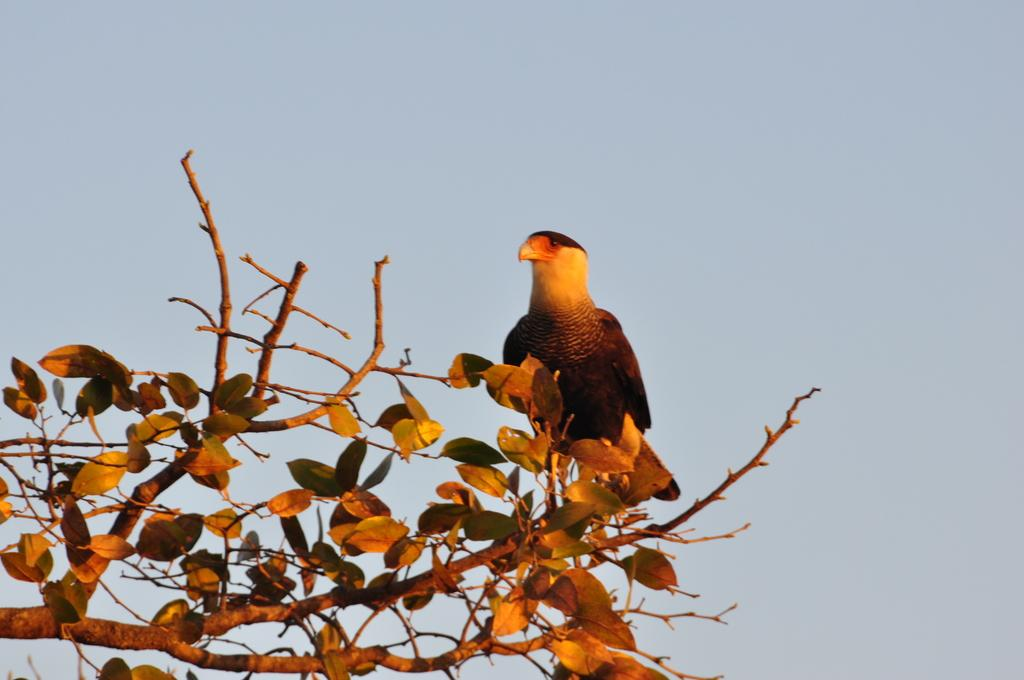What type of animal can be seen in the image? There is a bird in the image. Where is the bird located? The bird is on a tree. What colors can be seen on the bird? The bird has black and yellow coloring. What color is the sky in the image? The sky is blue in the image. What type of brass instrument is the bird playing in the image? There is no brass instrument present in the image, and the bird is not playing any instrument. 